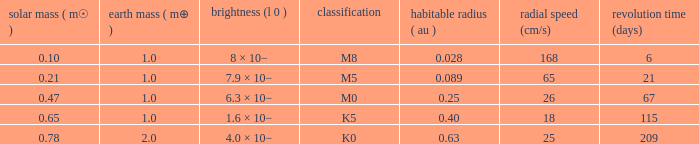What is the highest planetary mass having an RV (cm/s) of 65 and a Period (days) less than 21? None. 